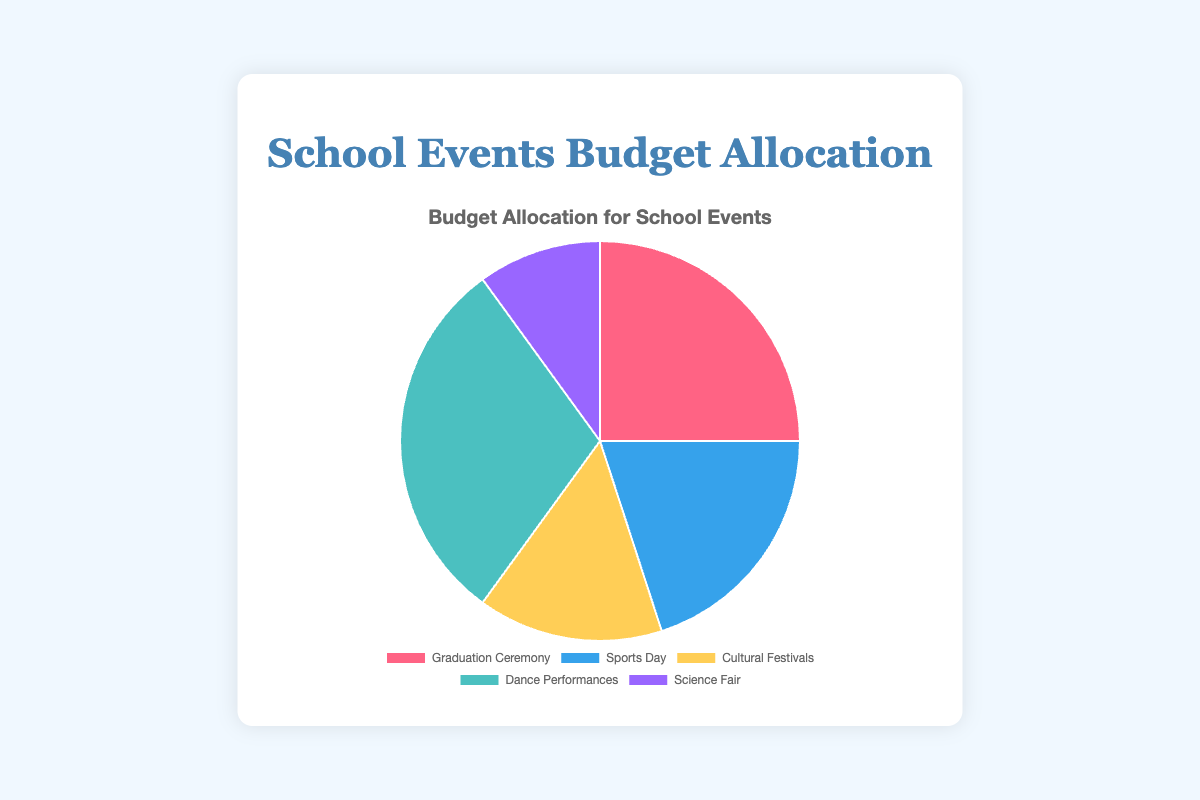What percentage of the budget is allocated to the Graduation Ceremony and Sports Day combined? Graduation Ceremony has 25% and Sports Day has 20%. Adding them together, 25% + 20% = 45%
Answer: 45% Which event has the highest budget allocation? By looking at the portions in the pie chart, Dance Performances has the highest budget allocation with 30%
Answer: Dance Performances Is the budget allocation for Cultural Festivals greater than that for the Science Fair? Cultural Festivals have a budget allocation of 15%, while the Science Fair has 10%. Comparing the two, 15% is greater than 10%
Answer: Yes How does the budget for Dance Performances compare to that of the Graduation Ceremony? Dance Performances have 30% of the budget, while Graduation Ceremony has 25%. Thus, Dance Performances have a higher budget allocation
Answer: Dance Performances have a higher budget What is the total budget percentage allocated to events other than Dance Performances? The total budget is 100%. Dance Performances take up 30%, so 100% - 30% = 70% is allocated to other events
Answer: 70% Which event has the smallest budget allocation, and what is its percentage? From the pie chart, the Science Fair has the smallest budget allocation with 10%
Answer: Science Fair, 10% If you combine the budget for the Graduation Ceremony, Cultural Festivals, and Science Fair, what fraction of the total budget is this? Graduation Ceremony is 25%, Cultural Festivals is 15%, and Science Fair is 10%. Adding these together, 25% + 15% + 10% = 50%
Answer: 50% What color is used to represent the budget for Cultural Festivals? The color representing Cultural Festivals in the pie chart is yellow
Answer: Yellow How much more budget does Dance Performances receive compared to Science Fair? Dance Performances get 30% of the budget, and Science Fair gets 10%. The difference is 30% - 10% = 20%
Answer: 20% What is the difference between the percentages allocated to the Sports Day and Cultural Festivals? Sports Day is allocated 20%, and Cultural Festivals are allocated 15%. The difference is 20% - 15% = 5%
Answer: 5% 